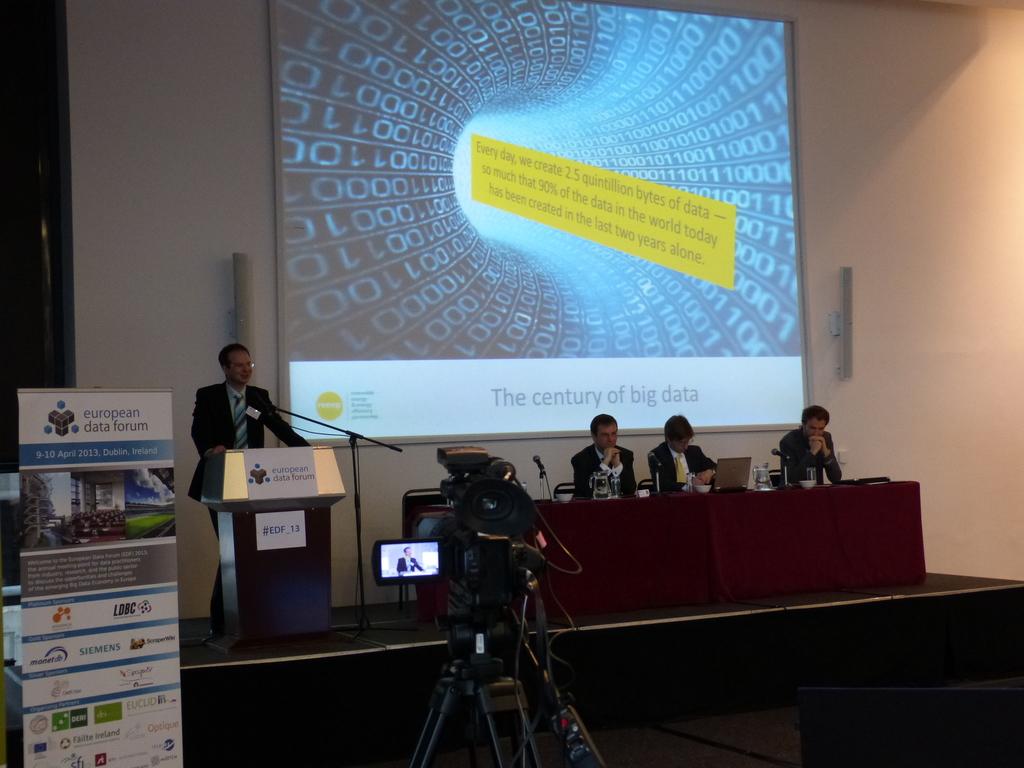What does the slogan read on the screen?
Keep it short and to the point. The century of big data. What does the slide say?
Your response must be concise. The century of big data. 